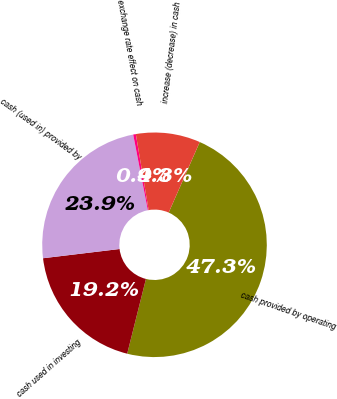Convert chart. <chart><loc_0><loc_0><loc_500><loc_500><pie_chart><fcel>cash provided by operating<fcel>cash used in investing<fcel>cash (used in) provided by<fcel>exchange rate effect on cash<fcel>increase (decrease) in cash<nl><fcel>47.31%<fcel>19.18%<fcel>23.87%<fcel>0.38%<fcel>9.26%<nl></chart> 